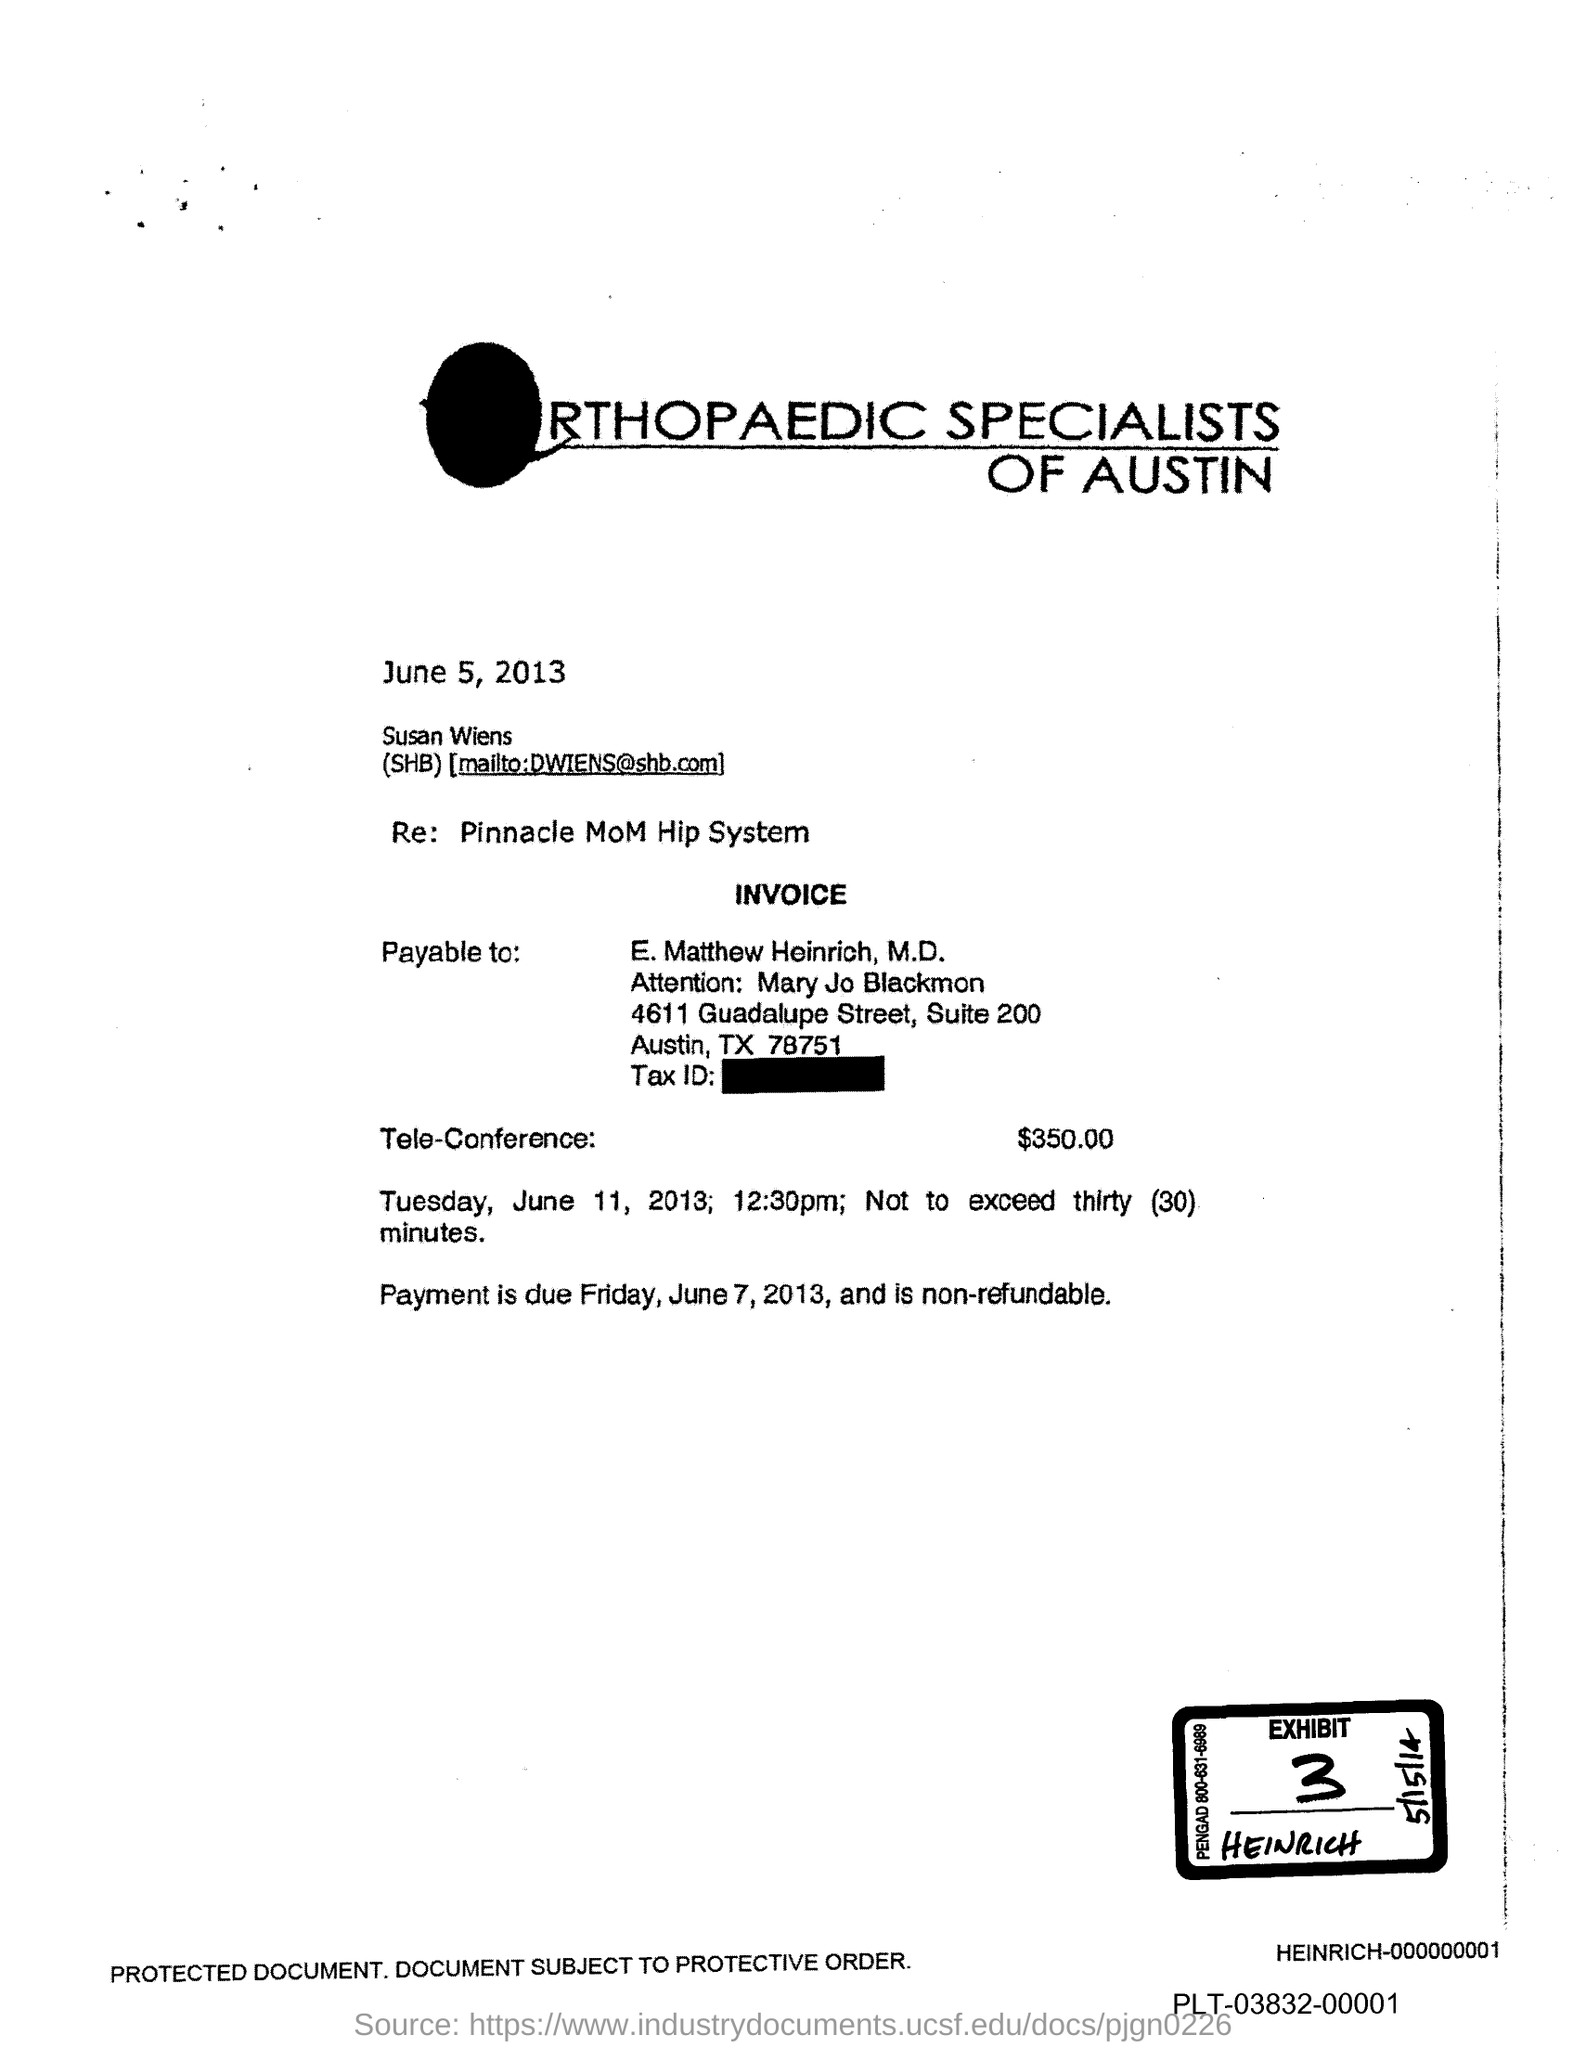Identify some key points in this picture. Please provide the exhibit number, which is 3. 